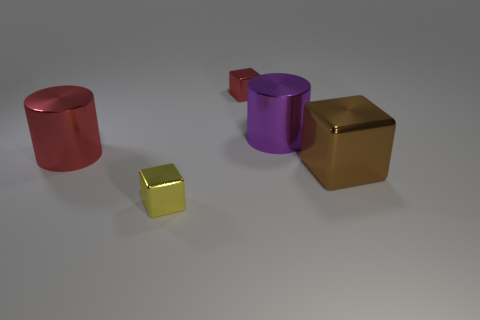Can you tell if the surface these objects are on reflects light differently than the objects themselves? Yes, the surface appears to have a matte finish with less glossiness compared to the shiny metallic finish of the objects. This results in softer reflections on the surface, offering a visual contrast to the high reflectivity of the objects. 